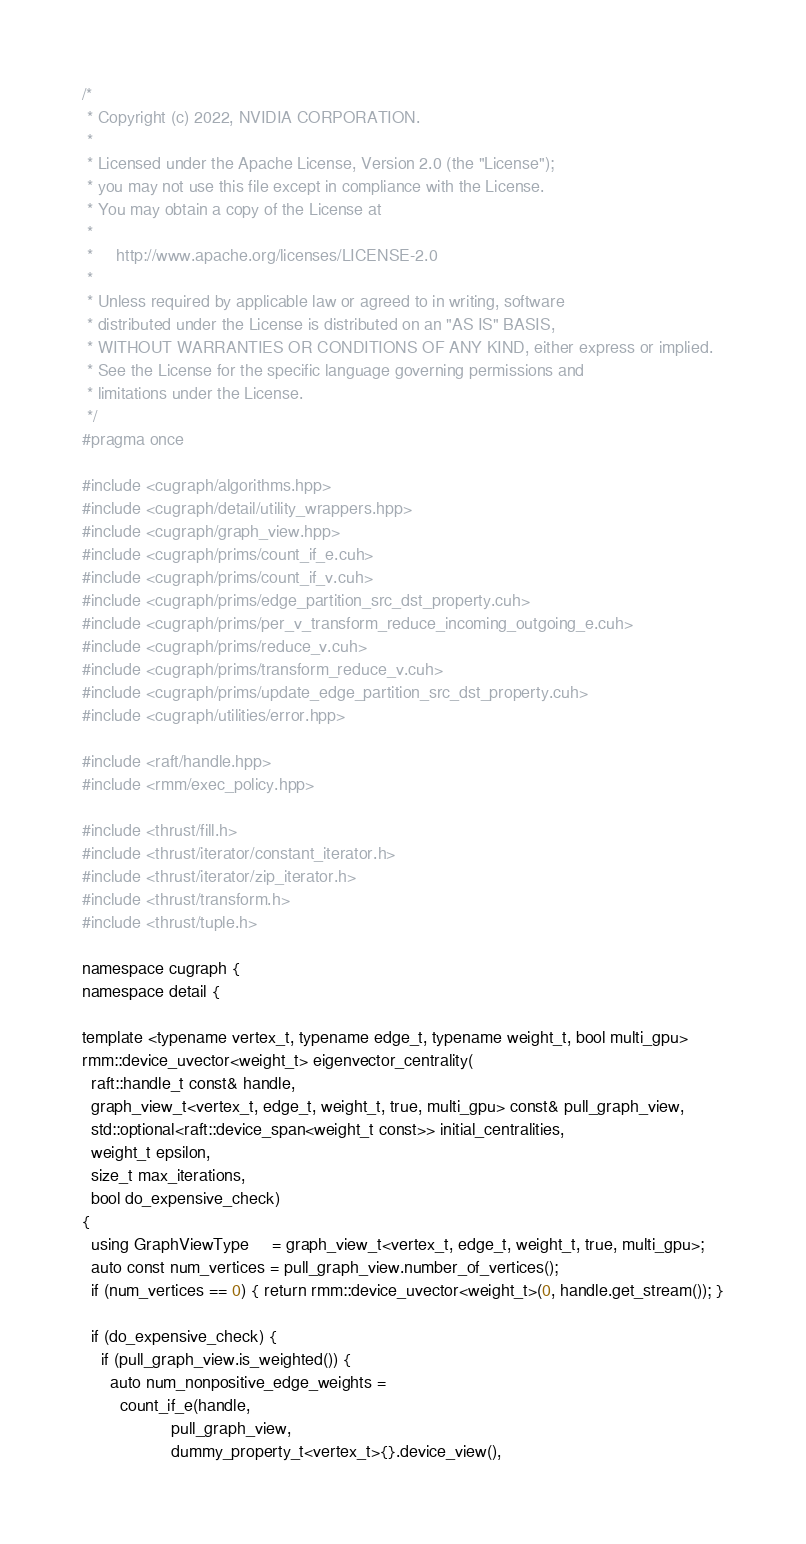Convert code to text. <code><loc_0><loc_0><loc_500><loc_500><_Cuda_>/*
 * Copyright (c) 2022, NVIDIA CORPORATION.
 *
 * Licensed under the Apache License, Version 2.0 (the "License");
 * you may not use this file except in compliance with the License.
 * You may obtain a copy of the License at
 *
 *     http://www.apache.org/licenses/LICENSE-2.0
 *
 * Unless required by applicable law or agreed to in writing, software
 * distributed under the License is distributed on an "AS IS" BASIS,
 * WITHOUT WARRANTIES OR CONDITIONS OF ANY KIND, either express or implied.
 * See the License for the specific language governing permissions and
 * limitations under the License.
 */
#pragma once

#include <cugraph/algorithms.hpp>
#include <cugraph/detail/utility_wrappers.hpp>
#include <cugraph/graph_view.hpp>
#include <cugraph/prims/count_if_e.cuh>
#include <cugraph/prims/count_if_v.cuh>
#include <cugraph/prims/edge_partition_src_dst_property.cuh>
#include <cugraph/prims/per_v_transform_reduce_incoming_outgoing_e.cuh>
#include <cugraph/prims/reduce_v.cuh>
#include <cugraph/prims/transform_reduce_v.cuh>
#include <cugraph/prims/update_edge_partition_src_dst_property.cuh>
#include <cugraph/utilities/error.hpp>

#include <raft/handle.hpp>
#include <rmm/exec_policy.hpp>

#include <thrust/fill.h>
#include <thrust/iterator/constant_iterator.h>
#include <thrust/iterator/zip_iterator.h>
#include <thrust/transform.h>
#include <thrust/tuple.h>

namespace cugraph {
namespace detail {

template <typename vertex_t, typename edge_t, typename weight_t, bool multi_gpu>
rmm::device_uvector<weight_t> eigenvector_centrality(
  raft::handle_t const& handle,
  graph_view_t<vertex_t, edge_t, weight_t, true, multi_gpu> const& pull_graph_view,
  std::optional<raft::device_span<weight_t const>> initial_centralities,
  weight_t epsilon,
  size_t max_iterations,
  bool do_expensive_check)
{
  using GraphViewType     = graph_view_t<vertex_t, edge_t, weight_t, true, multi_gpu>;
  auto const num_vertices = pull_graph_view.number_of_vertices();
  if (num_vertices == 0) { return rmm::device_uvector<weight_t>(0, handle.get_stream()); }

  if (do_expensive_check) {
    if (pull_graph_view.is_weighted()) {
      auto num_nonpositive_edge_weights =
        count_if_e(handle,
                   pull_graph_view,
                   dummy_property_t<vertex_t>{}.device_view(),</code> 